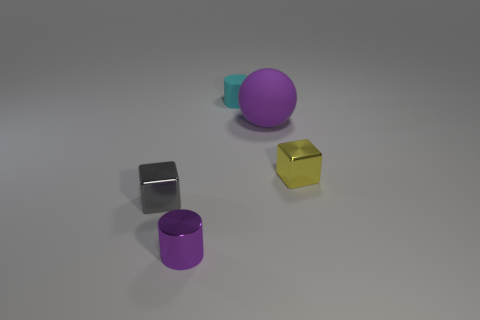Subtract all gray cylinders. Subtract all gray blocks. How many cylinders are left? 2 Add 2 gray metal blocks. How many objects exist? 7 Subtract all balls. How many objects are left? 4 Add 4 small gray metal blocks. How many small gray metal blocks exist? 5 Subtract 0 brown blocks. How many objects are left? 5 Subtract all purple matte balls. Subtract all tiny gray shiny things. How many objects are left? 3 Add 4 purple cylinders. How many purple cylinders are left? 5 